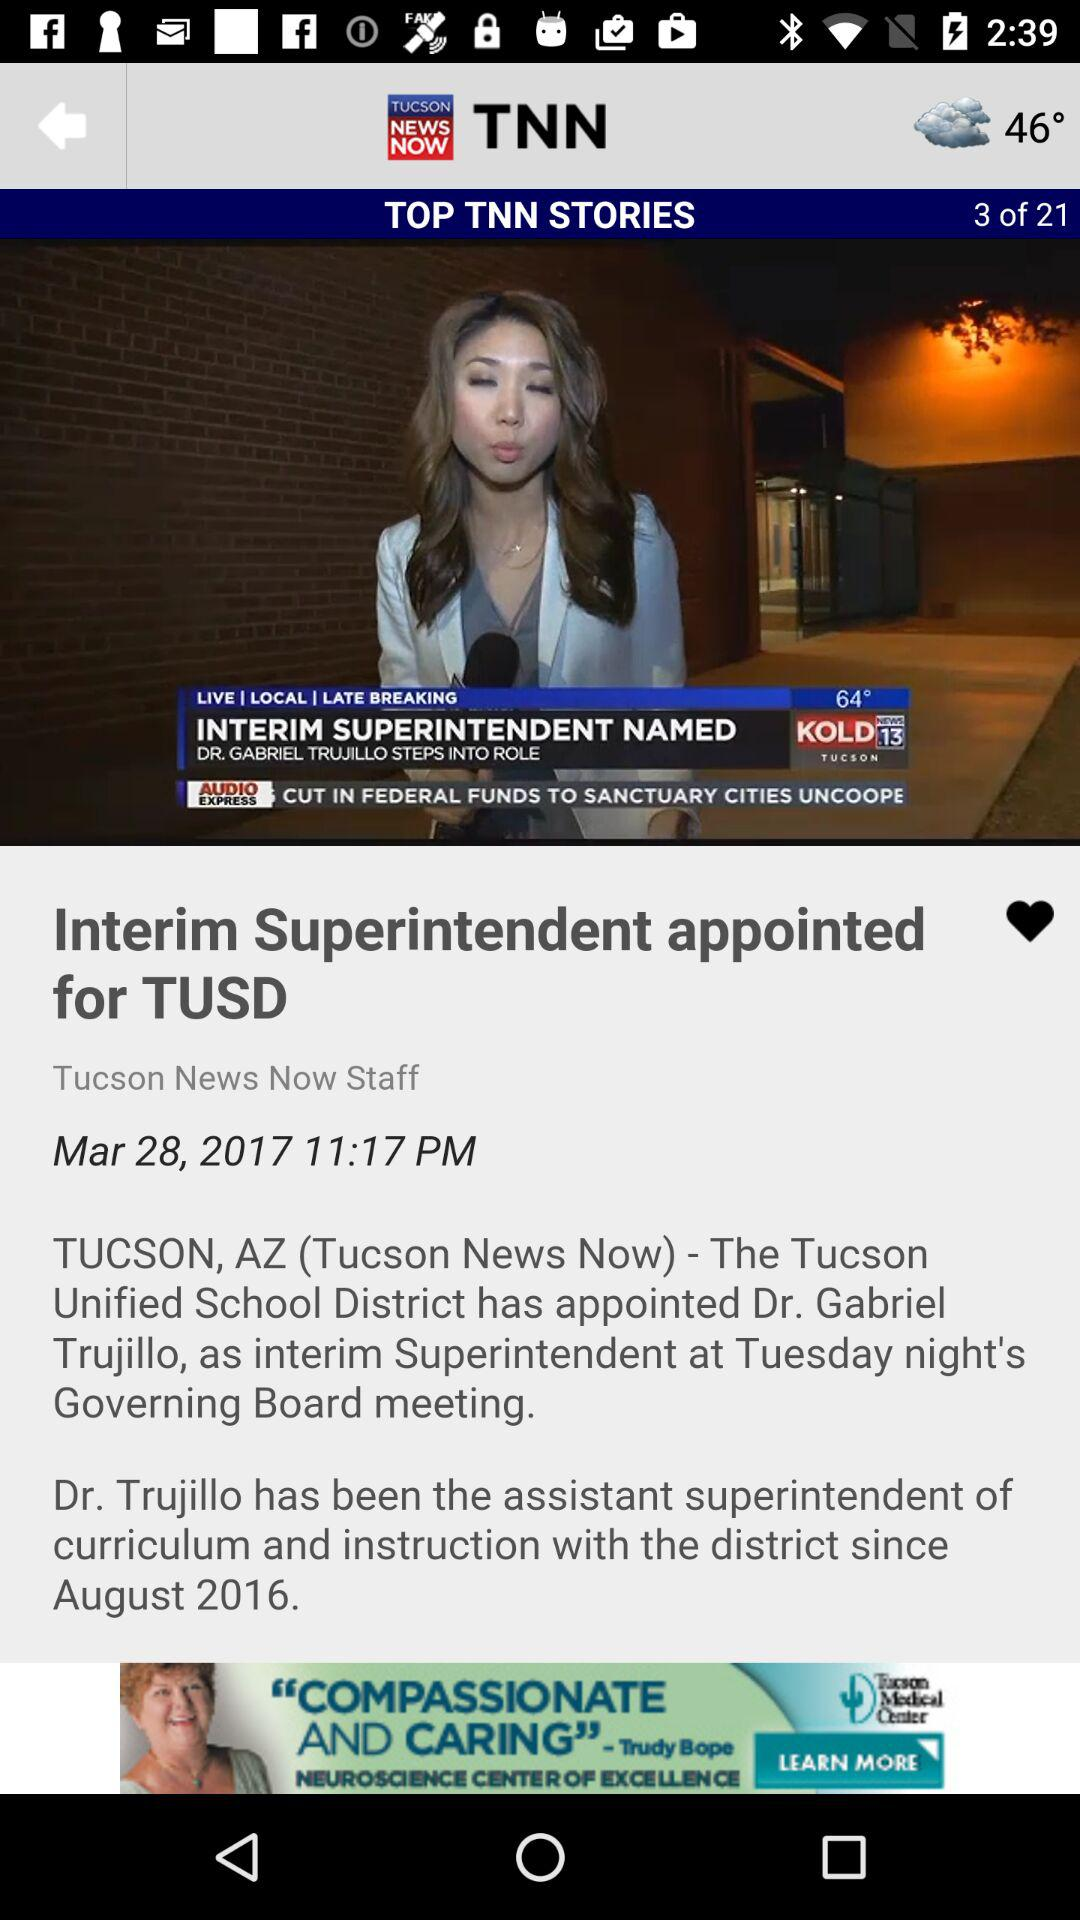On what date was the story "Interim Superintendent appointed for TUSD" posted? The story was posted on March 28, 2017. 